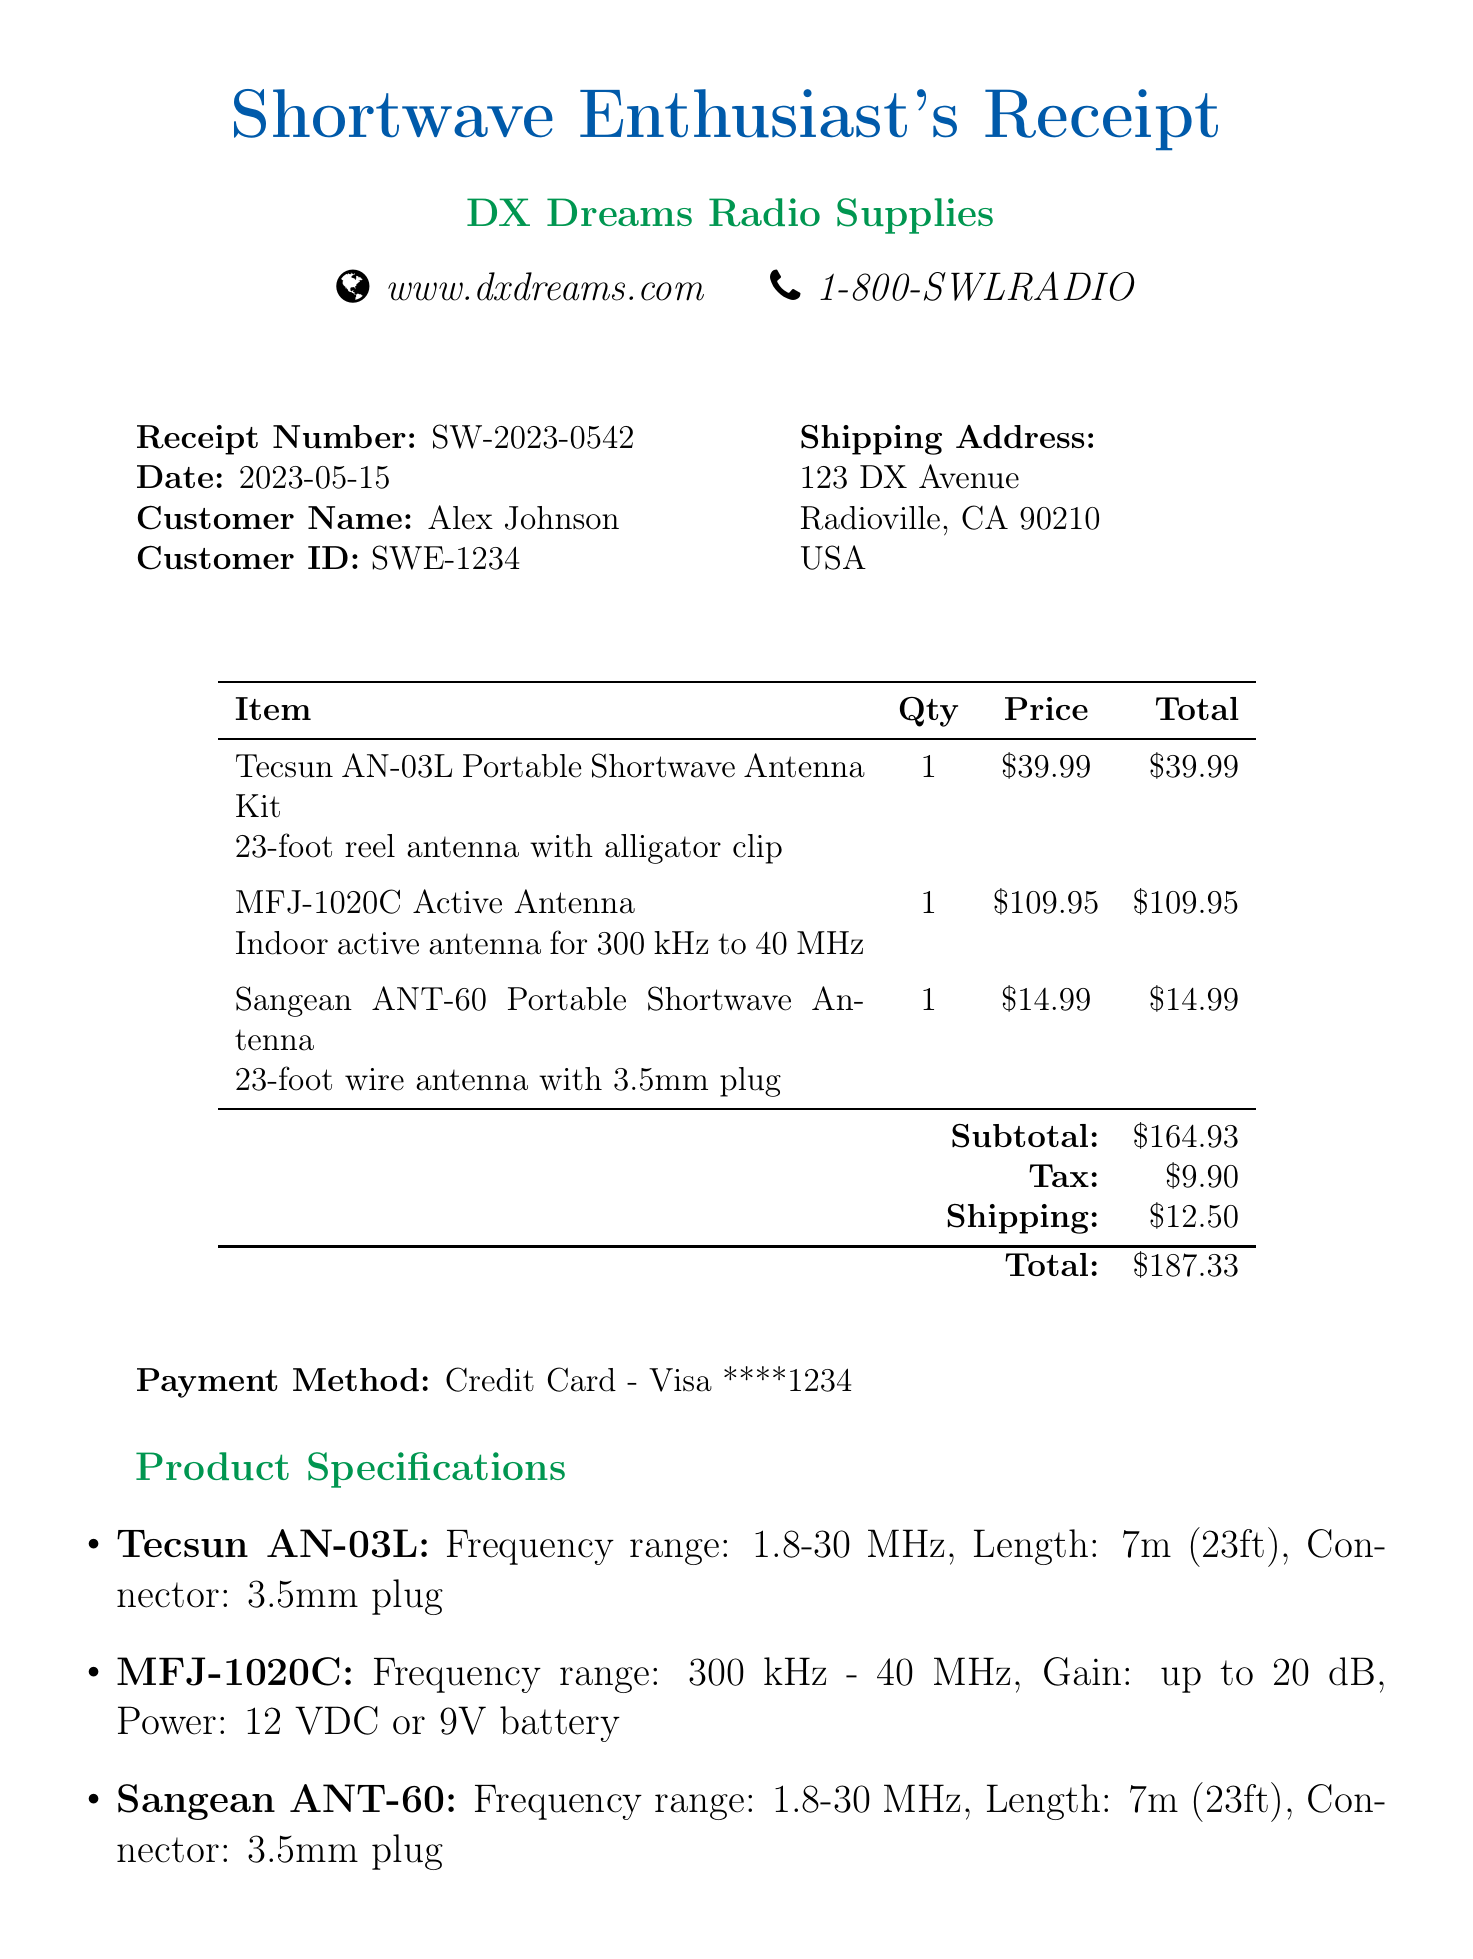What is the receipt number? The receipt number is a unique identifier for the transaction, presented clearly at the top of the document.
Answer: SW-2023-0542 What is the total amount charged? The total amount charged is the final amount the customer needs to pay for the items, calculated from the subtotal plus tax and shipping.
Answer: $187.33 Who is the customer? The customer is the individual who made the purchase, listed at the beginning of the document.
Answer: Alex Johnson How many items were purchased? The total number of items is obtained by counting the entries listed in the itemized section of the receipt.
Answer: 3 What is the frequency range of the MFJ-1020C? The frequency range expresses the operational capability of the antenna, specified in the product specifications section.
Answer: 300 kHz - 40 MHz What payment method was used for the purchase? The payment method indicates how the customer settled the transaction, outlined in the payment section of the receipt.
Answer: Credit Card - Visa ****1234 What is the purpose of the alligator clip in the antenna kit? The purpose revolves around improving the performance of the antenna by connecting it to a ground point or metal object for better reception, as detailed in the assembly instructions.
Answer: Improved reception What should be done for optimal antenna performance indoors? This question requires understanding of step five in the assembly instructions that advises on optimal usage conditions for the antenna.
Answer: Near a window What is provided in the additional notes? The additional notes section gives further recommendations related to the performance of the antennas and considerations for usage.
Answer: Optimal performance advice 